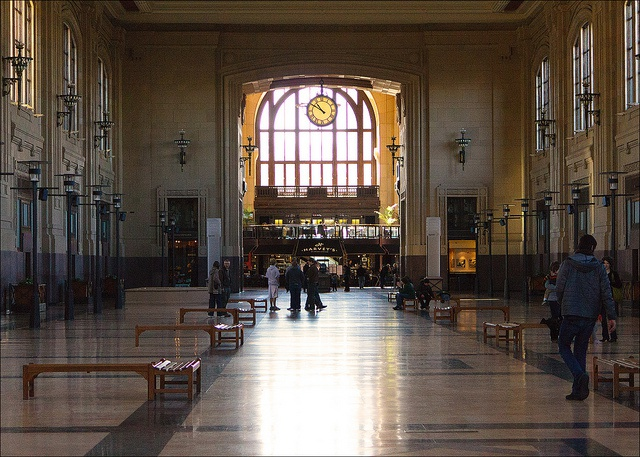Describe the objects in this image and their specific colors. I can see people in black, maroon, and gray tones, bench in black, maroon, and gray tones, bench in black, maroon, and gray tones, bench in black, maroon, and gray tones, and people in black, maroon, and gray tones in this image. 